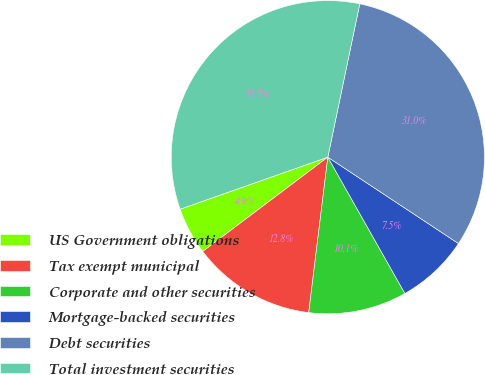Convert chart to OTSL. <chart><loc_0><loc_0><loc_500><loc_500><pie_chart><fcel>US Government obligations<fcel>Tax exempt municipal<fcel>Corporate and other securities<fcel>Mortgage-backed securities<fcel>Debt securities<fcel>Total investment securities<nl><fcel>4.89%<fcel>12.77%<fcel>10.14%<fcel>7.51%<fcel>31.03%<fcel>33.66%<nl></chart> 